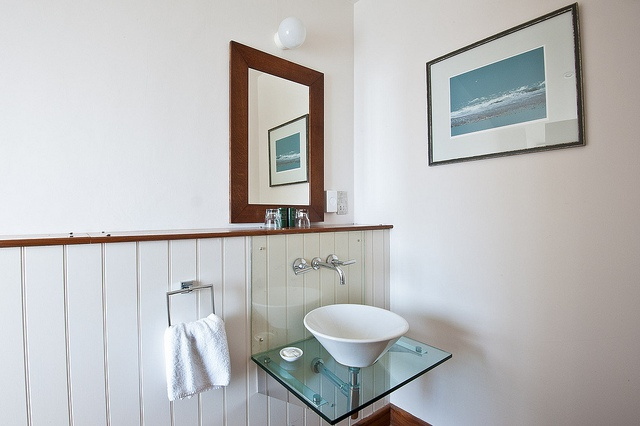Describe the objects in this image and their specific colors. I can see sink in lightgray, darkgray, and gray tones, cup in lightgray, darkgray, and gray tones, and cup in lightgray, gray, darkgray, and maroon tones in this image. 